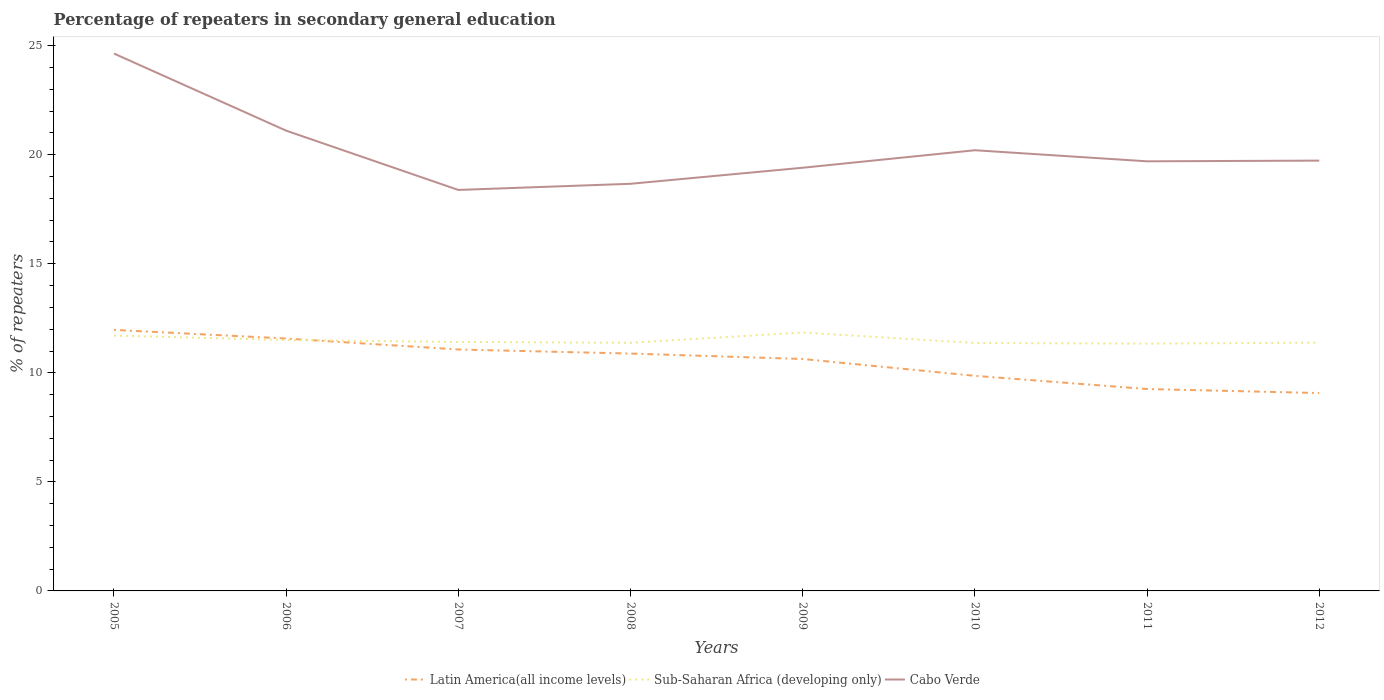Is the number of lines equal to the number of legend labels?
Make the answer very short. Yes. Across all years, what is the maximum percentage of repeaters in secondary general education in Cabo Verde?
Offer a terse response. 18.38. What is the total percentage of repeaters in secondary general education in Cabo Verde in the graph?
Offer a terse response. -0.29. What is the difference between the highest and the second highest percentage of repeaters in secondary general education in Cabo Verde?
Ensure brevity in your answer.  6.25. Is the percentage of repeaters in secondary general education in Cabo Verde strictly greater than the percentage of repeaters in secondary general education in Latin America(all income levels) over the years?
Give a very brief answer. No. How many years are there in the graph?
Ensure brevity in your answer.  8. Are the values on the major ticks of Y-axis written in scientific E-notation?
Make the answer very short. No. How many legend labels are there?
Ensure brevity in your answer.  3. What is the title of the graph?
Provide a short and direct response. Percentage of repeaters in secondary general education. Does "Poland" appear as one of the legend labels in the graph?
Your response must be concise. No. What is the label or title of the Y-axis?
Provide a succinct answer. % of repeaters. What is the % of repeaters of Latin America(all income levels) in 2005?
Your answer should be very brief. 11.97. What is the % of repeaters of Sub-Saharan Africa (developing only) in 2005?
Provide a short and direct response. 11.71. What is the % of repeaters of Cabo Verde in 2005?
Ensure brevity in your answer.  24.64. What is the % of repeaters of Latin America(all income levels) in 2006?
Ensure brevity in your answer.  11.57. What is the % of repeaters in Sub-Saharan Africa (developing only) in 2006?
Give a very brief answer. 11.5. What is the % of repeaters of Cabo Verde in 2006?
Offer a terse response. 21.1. What is the % of repeaters of Latin America(all income levels) in 2007?
Offer a very short reply. 11.07. What is the % of repeaters of Sub-Saharan Africa (developing only) in 2007?
Keep it short and to the point. 11.41. What is the % of repeaters in Cabo Verde in 2007?
Provide a succinct answer. 18.38. What is the % of repeaters of Latin America(all income levels) in 2008?
Provide a succinct answer. 10.88. What is the % of repeaters in Sub-Saharan Africa (developing only) in 2008?
Give a very brief answer. 11.38. What is the % of repeaters in Cabo Verde in 2008?
Offer a terse response. 18.67. What is the % of repeaters in Latin America(all income levels) in 2009?
Offer a terse response. 10.63. What is the % of repeaters of Sub-Saharan Africa (developing only) in 2009?
Provide a succinct answer. 11.85. What is the % of repeaters in Cabo Verde in 2009?
Keep it short and to the point. 19.4. What is the % of repeaters of Latin America(all income levels) in 2010?
Provide a succinct answer. 9.86. What is the % of repeaters in Sub-Saharan Africa (developing only) in 2010?
Provide a succinct answer. 11.37. What is the % of repeaters of Cabo Verde in 2010?
Make the answer very short. 20.2. What is the % of repeaters of Latin America(all income levels) in 2011?
Give a very brief answer. 9.26. What is the % of repeaters in Sub-Saharan Africa (developing only) in 2011?
Give a very brief answer. 11.34. What is the % of repeaters of Cabo Verde in 2011?
Ensure brevity in your answer.  19.7. What is the % of repeaters of Latin America(all income levels) in 2012?
Ensure brevity in your answer.  9.07. What is the % of repeaters in Sub-Saharan Africa (developing only) in 2012?
Provide a short and direct response. 11.38. What is the % of repeaters in Cabo Verde in 2012?
Make the answer very short. 19.73. Across all years, what is the maximum % of repeaters of Latin America(all income levels)?
Make the answer very short. 11.97. Across all years, what is the maximum % of repeaters in Sub-Saharan Africa (developing only)?
Provide a succinct answer. 11.85. Across all years, what is the maximum % of repeaters in Cabo Verde?
Your response must be concise. 24.64. Across all years, what is the minimum % of repeaters of Latin America(all income levels)?
Your answer should be very brief. 9.07. Across all years, what is the minimum % of repeaters of Sub-Saharan Africa (developing only)?
Keep it short and to the point. 11.34. Across all years, what is the minimum % of repeaters of Cabo Verde?
Your answer should be very brief. 18.38. What is the total % of repeaters in Latin America(all income levels) in the graph?
Make the answer very short. 84.32. What is the total % of repeaters of Sub-Saharan Africa (developing only) in the graph?
Offer a very short reply. 91.94. What is the total % of repeaters of Cabo Verde in the graph?
Your response must be concise. 161.82. What is the difference between the % of repeaters of Latin America(all income levels) in 2005 and that in 2006?
Keep it short and to the point. 0.4. What is the difference between the % of repeaters of Sub-Saharan Africa (developing only) in 2005 and that in 2006?
Your answer should be very brief. 0.2. What is the difference between the % of repeaters in Cabo Verde in 2005 and that in 2006?
Make the answer very short. 3.53. What is the difference between the % of repeaters of Latin America(all income levels) in 2005 and that in 2007?
Ensure brevity in your answer.  0.9. What is the difference between the % of repeaters of Sub-Saharan Africa (developing only) in 2005 and that in 2007?
Keep it short and to the point. 0.29. What is the difference between the % of repeaters in Cabo Verde in 2005 and that in 2007?
Provide a succinct answer. 6.25. What is the difference between the % of repeaters in Latin America(all income levels) in 2005 and that in 2008?
Your answer should be compact. 1.09. What is the difference between the % of repeaters in Sub-Saharan Africa (developing only) in 2005 and that in 2008?
Keep it short and to the point. 0.33. What is the difference between the % of repeaters of Cabo Verde in 2005 and that in 2008?
Keep it short and to the point. 5.97. What is the difference between the % of repeaters of Latin America(all income levels) in 2005 and that in 2009?
Your answer should be very brief. 1.33. What is the difference between the % of repeaters in Sub-Saharan Africa (developing only) in 2005 and that in 2009?
Offer a very short reply. -0.14. What is the difference between the % of repeaters of Cabo Verde in 2005 and that in 2009?
Ensure brevity in your answer.  5.24. What is the difference between the % of repeaters in Latin America(all income levels) in 2005 and that in 2010?
Make the answer very short. 2.11. What is the difference between the % of repeaters of Sub-Saharan Africa (developing only) in 2005 and that in 2010?
Provide a succinct answer. 0.34. What is the difference between the % of repeaters in Cabo Verde in 2005 and that in 2010?
Make the answer very short. 4.43. What is the difference between the % of repeaters in Latin America(all income levels) in 2005 and that in 2011?
Your response must be concise. 2.71. What is the difference between the % of repeaters in Sub-Saharan Africa (developing only) in 2005 and that in 2011?
Provide a succinct answer. 0.37. What is the difference between the % of repeaters in Cabo Verde in 2005 and that in 2011?
Offer a terse response. 4.94. What is the difference between the % of repeaters of Latin America(all income levels) in 2005 and that in 2012?
Give a very brief answer. 2.9. What is the difference between the % of repeaters in Sub-Saharan Africa (developing only) in 2005 and that in 2012?
Provide a short and direct response. 0.32. What is the difference between the % of repeaters in Cabo Verde in 2005 and that in 2012?
Your response must be concise. 4.91. What is the difference between the % of repeaters of Latin America(all income levels) in 2006 and that in 2007?
Your response must be concise. 0.5. What is the difference between the % of repeaters of Sub-Saharan Africa (developing only) in 2006 and that in 2007?
Ensure brevity in your answer.  0.09. What is the difference between the % of repeaters of Cabo Verde in 2006 and that in 2007?
Your answer should be compact. 2.72. What is the difference between the % of repeaters in Latin America(all income levels) in 2006 and that in 2008?
Keep it short and to the point. 0.69. What is the difference between the % of repeaters in Sub-Saharan Africa (developing only) in 2006 and that in 2008?
Your answer should be very brief. 0.12. What is the difference between the % of repeaters in Cabo Verde in 2006 and that in 2008?
Make the answer very short. 2.44. What is the difference between the % of repeaters of Latin America(all income levels) in 2006 and that in 2009?
Offer a terse response. 0.94. What is the difference between the % of repeaters of Sub-Saharan Africa (developing only) in 2006 and that in 2009?
Offer a terse response. -0.35. What is the difference between the % of repeaters of Cabo Verde in 2006 and that in 2009?
Offer a terse response. 1.7. What is the difference between the % of repeaters of Latin America(all income levels) in 2006 and that in 2010?
Ensure brevity in your answer.  1.71. What is the difference between the % of repeaters of Sub-Saharan Africa (developing only) in 2006 and that in 2010?
Your answer should be compact. 0.14. What is the difference between the % of repeaters of Cabo Verde in 2006 and that in 2010?
Your response must be concise. 0.9. What is the difference between the % of repeaters of Latin America(all income levels) in 2006 and that in 2011?
Your answer should be very brief. 2.31. What is the difference between the % of repeaters of Sub-Saharan Africa (developing only) in 2006 and that in 2011?
Your response must be concise. 0.16. What is the difference between the % of repeaters of Cabo Verde in 2006 and that in 2011?
Ensure brevity in your answer.  1.41. What is the difference between the % of repeaters of Latin America(all income levels) in 2006 and that in 2012?
Your answer should be very brief. 2.5. What is the difference between the % of repeaters in Sub-Saharan Africa (developing only) in 2006 and that in 2012?
Your answer should be very brief. 0.12. What is the difference between the % of repeaters of Cabo Verde in 2006 and that in 2012?
Offer a terse response. 1.37. What is the difference between the % of repeaters of Latin America(all income levels) in 2007 and that in 2008?
Your answer should be compact. 0.19. What is the difference between the % of repeaters in Sub-Saharan Africa (developing only) in 2007 and that in 2008?
Offer a terse response. 0.04. What is the difference between the % of repeaters of Cabo Verde in 2007 and that in 2008?
Provide a short and direct response. -0.28. What is the difference between the % of repeaters in Latin America(all income levels) in 2007 and that in 2009?
Provide a short and direct response. 0.44. What is the difference between the % of repeaters of Sub-Saharan Africa (developing only) in 2007 and that in 2009?
Provide a short and direct response. -0.43. What is the difference between the % of repeaters in Cabo Verde in 2007 and that in 2009?
Your response must be concise. -1.02. What is the difference between the % of repeaters of Latin America(all income levels) in 2007 and that in 2010?
Your response must be concise. 1.21. What is the difference between the % of repeaters in Sub-Saharan Africa (developing only) in 2007 and that in 2010?
Your answer should be very brief. 0.05. What is the difference between the % of repeaters in Cabo Verde in 2007 and that in 2010?
Your answer should be compact. -1.82. What is the difference between the % of repeaters in Latin America(all income levels) in 2007 and that in 2011?
Your answer should be compact. 1.81. What is the difference between the % of repeaters of Sub-Saharan Africa (developing only) in 2007 and that in 2011?
Keep it short and to the point. 0.08. What is the difference between the % of repeaters of Cabo Verde in 2007 and that in 2011?
Your answer should be very brief. -1.31. What is the difference between the % of repeaters of Latin America(all income levels) in 2007 and that in 2012?
Give a very brief answer. 2. What is the difference between the % of repeaters of Sub-Saharan Africa (developing only) in 2007 and that in 2012?
Ensure brevity in your answer.  0.03. What is the difference between the % of repeaters of Cabo Verde in 2007 and that in 2012?
Offer a terse response. -1.34. What is the difference between the % of repeaters in Latin America(all income levels) in 2008 and that in 2009?
Provide a short and direct response. 0.25. What is the difference between the % of repeaters in Sub-Saharan Africa (developing only) in 2008 and that in 2009?
Offer a terse response. -0.47. What is the difference between the % of repeaters of Cabo Verde in 2008 and that in 2009?
Provide a succinct answer. -0.74. What is the difference between the % of repeaters in Latin America(all income levels) in 2008 and that in 2010?
Your response must be concise. 1.02. What is the difference between the % of repeaters in Sub-Saharan Africa (developing only) in 2008 and that in 2010?
Ensure brevity in your answer.  0.01. What is the difference between the % of repeaters in Cabo Verde in 2008 and that in 2010?
Keep it short and to the point. -1.54. What is the difference between the % of repeaters of Latin America(all income levels) in 2008 and that in 2011?
Provide a succinct answer. 1.62. What is the difference between the % of repeaters of Sub-Saharan Africa (developing only) in 2008 and that in 2011?
Give a very brief answer. 0.04. What is the difference between the % of repeaters in Cabo Verde in 2008 and that in 2011?
Give a very brief answer. -1.03. What is the difference between the % of repeaters in Latin America(all income levels) in 2008 and that in 2012?
Provide a short and direct response. 1.81. What is the difference between the % of repeaters of Sub-Saharan Africa (developing only) in 2008 and that in 2012?
Your response must be concise. -0. What is the difference between the % of repeaters of Cabo Verde in 2008 and that in 2012?
Your answer should be very brief. -1.06. What is the difference between the % of repeaters in Latin America(all income levels) in 2009 and that in 2010?
Provide a succinct answer. 0.77. What is the difference between the % of repeaters in Sub-Saharan Africa (developing only) in 2009 and that in 2010?
Your answer should be very brief. 0.48. What is the difference between the % of repeaters of Cabo Verde in 2009 and that in 2010?
Your answer should be very brief. -0.8. What is the difference between the % of repeaters of Latin America(all income levels) in 2009 and that in 2011?
Provide a succinct answer. 1.38. What is the difference between the % of repeaters of Sub-Saharan Africa (developing only) in 2009 and that in 2011?
Your response must be concise. 0.51. What is the difference between the % of repeaters of Cabo Verde in 2009 and that in 2011?
Keep it short and to the point. -0.29. What is the difference between the % of repeaters in Latin America(all income levels) in 2009 and that in 2012?
Your answer should be compact. 1.56. What is the difference between the % of repeaters of Sub-Saharan Africa (developing only) in 2009 and that in 2012?
Make the answer very short. 0.47. What is the difference between the % of repeaters of Cabo Verde in 2009 and that in 2012?
Offer a very short reply. -0.33. What is the difference between the % of repeaters of Latin America(all income levels) in 2010 and that in 2011?
Your response must be concise. 0.6. What is the difference between the % of repeaters in Sub-Saharan Africa (developing only) in 2010 and that in 2011?
Make the answer very short. 0.03. What is the difference between the % of repeaters of Cabo Verde in 2010 and that in 2011?
Give a very brief answer. 0.51. What is the difference between the % of repeaters of Latin America(all income levels) in 2010 and that in 2012?
Make the answer very short. 0.79. What is the difference between the % of repeaters in Sub-Saharan Africa (developing only) in 2010 and that in 2012?
Your response must be concise. -0.01. What is the difference between the % of repeaters of Cabo Verde in 2010 and that in 2012?
Provide a short and direct response. 0.48. What is the difference between the % of repeaters of Latin America(all income levels) in 2011 and that in 2012?
Give a very brief answer. 0.18. What is the difference between the % of repeaters of Sub-Saharan Africa (developing only) in 2011 and that in 2012?
Your answer should be compact. -0.04. What is the difference between the % of repeaters in Cabo Verde in 2011 and that in 2012?
Your answer should be compact. -0.03. What is the difference between the % of repeaters in Latin America(all income levels) in 2005 and the % of repeaters in Sub-Saharan Africa (developing only) in 2006?
Give a very brief answer. 0.47. What is the difference between the % of repeaters of Latin America(all income levels) in 2005 and the % of repeaters of Cabo Verde in 2006?
Provide a short and direct response. -9.13. What is the difference between the % of repeaters in Sub-Saharan Africa (developing only) in 2005 and the % of repeaters in Cabo Verde in 2006?
Ensure brevity in your answer.  -9.4. What is the difference between the % of repeaters in Latin America(all income levels) in 2005 and the % of repeaters in Sub-Saharan Africa (developing only) in 2007?
Your response must be concise. 0.55. What is the difference between the % of repeaters in Latin America(all income levels) in 2005 and the % of repeaters in Cabo Verde in 2007?
Provide a succinct answer. -6.42. What is the difference between the % of repeaters in Sub-Saharan Africa (developing only) in 2005 and the % of repeaters in Cabo Verde in 2007?
Provide a succinct answer. -6.68. What is the difference between the % of repeaters of Latin America(all income levels) in 2005 and the % of repeaters of Sub-Saharan Africa (developing only) in 2008?
Offer a terse response. 0.59. What is the difference between the % of repeaters of Latin America(all income levels) in 2005 and the % of repeaters of Cabo Verde in 2008?
Your response must be concise. -6.7. What is the difference between the % of repeaters in Sub-Saharan Africa (developing only) in 2005 and the % of repeaters in Cabo Verde in 2008?
Keep it short and to the point. -6.96. What is the difference between the % of repeaters in Latin America(all income levels) in 2005 and the % of repeaters in Sub-Saharan Africa (developing only) in 2009?
Provide a succinct answer. 0.12. What is the difference between the % of repeaters in Latin America(all income levels) in 2005 and the % of repeaters in Cabo Verde in 2009?
Offer a very short reply. -7.43. What is the difference between the % of repeaters of Sub-Saharan Africa (developing only) in 2005 and the % of repeaters of Cabo Verde in 2009?
Give a very brief answer. -7.7. What is the difference between the % of repeaters in Latin America(all income levels) in 2005 and the % of repeaters in Sub-Saharan Africa (developing only) in 2010?
Offer a very short reply. 0.6. What is the difference between the % of repeaters of Latin America(all income levels) in 2005 and the % of repeaters of Cabo Verde in 2010?
Your answer should be compact. -8.24. What is the difference between the % of repeaters of Sub-Saharan Africa (developing only) in 2005 and the % of repeaters of Cabo Verde in 2010?
Provide a short and direct response. -8.5. What is the difference between the % of repeaters of Latin America(all income levels) in 2005 and the % of repeaters of Sub-Saharan Africa (developing only) in 2011?
Keep it short and to the point. 0.63. What is the difference between the % of repeaters in Latin America(all income levels) in 2005 and the % of repeaters in Cabo Verde in 2011?
Ensure brevity in your answer.  -7.73. What is the difference between the % of repeaters in Sub-Saharan Africa (developing only) in 2005 and the % of repeaters in Cabo Verde in 2011?
Ensure brevity in your answer.  -7.99. What is the difference between the % of repeaters of Latin America(all income levels) in 2005 and the % of repeaters of Sub-Saharan Africa (developing only) in 2012?
Your answer should be very brief. 0.59. What is the difference between the % of repeaters in Latin America(all income levels) in 2005 and the % of repeaters in Cabo Verde in 2012?
Provide a short and direct response. -7.76. What is the difference between the % of repeaters of Sub-Saharan Africa (developing only) in 2005 and the % of repeaters of Cabo Verde in 2012?
Provide a succinct answer. -8.02. What is the difference between the % of repeaters in Latin America(all income levels) in 2006 and the % of repeaters in Sub-Saharan Africa (developing only) in 2007?
Ensure brevity in your answer.  0.16. What is the difference between the % of repeaters in Latin America(all income levels) in 2006 and the % of repeaters in Cabo Verde in 2007?
Your answer should be very brief. -6.81. What is the difference between the % of repeaters of Sub-Saharan Africa (developing only) in 2006 and the % of repeaters of Cabo Verde in 2007?
Your answer should be compact. -6.88. What is the difference between the % of repeaters in Latin America(all income levels) in 2006 and the % of repeaters in Sub-Saharan Africa (developing only) in 2008?
Ensure brevity in your answer.  0.19. What is the difference between the % of repeaters in Latin America(all income levels) in 2006 and the % of repeaters in Cabo Verde in 2008?
Provide a short and direct response. -7.1. What is the difference between the % of repeaters of Sub-Saharan Africa (developing only) in 2006 and the % of repeaters of Cabo Verde in 2008?
Offer a very short reply. -7.16. What is the difference between the % of repeaters of Latin America(all income levels) in 2006 and the % of repeaters of Sub-Saharan Africa (developing only) in 2009?
Keep it short and to the point. -0.28. What is the difference between the % of repeaters of Latin America(all income levels) in 2006 and the % of repeaters of Cabo Verde in 2009?
Ensure brevity in your answer.  -7.83. What is the difference between the % of repeaters in Sub-Saharan Africa (developing only) in 2006 and the % of repeaters in Cabo Verde in 2009?
Your response must be concise. -7.9. What is the difference between the % of repeaters in Latin America(all income levels) in 2006 and the % of repeaters in Sub-Saharan Africa (developing only) in 2010?
Provide a short and direct response. 0.2. What is the difference between the % of repeaters in Latin America(all income levels) in 2006 and the % of repeaters in Cabo Verde in 2010?
Ensure brevity in your answer.  -8.63. What is the difference between the % of repeaters of Sub-Saharan Africa (developing only) in 2006 and the % of repeaters of Cabo Verde in 2010?
Offer a very short reply. -8.7. What is the difference between the % of repeaters in Latin America(all income levels) in 2006 and the % of repeaters in Sub-Saharan Africa (developing only) in 2011?
Ensure brevity in your answer.  0.23. What is the difference between the % of repeaters of Latin America(all income levels) in 2006 and the % of repeaters of Cabo Verde in 2011?
Make the answer very short. -8.13. What is the difference between the % of repeaters of Sub-Saharan Africa (developing only) in 2006 and the % of repeaters of Cabo Verde in 2011?
Your answer should be compact. -8.19. What is the difference between the % of repeaters in Latin America(all income levels) in 2006 and the % of repeaters in Sub-Saharan Africa (developing only) in 2012?
Keep it short and to the point. 0.19. What is the difference between the % of repeaters in Latin America(all income levels) in 2006 and the % of repeaters in Cabo Verde in 2012?
Offer a terse response. -8.16. What is the difference between the % of repeaters in Sub-Saharan Africa (developing only) in 2006 and the % of repeaters in Cabo Verde in 2012?
Make the answer very short. -8.23. What is the difference between the % of repeaters of Latin America(all income levels) in 2007 and the % of repeaters of Sub-Saharan Africa (developing only) in 2008?
Ensure brevity in your answer.  -0.31. What is the difference between the % of repeaters of Latin America(all income levels) in 2007 and the % of repeaters of Cabo Verde in 2008?
Provide a succinct answer. -7.6. What is the difference between the % of repeaters in Sub-Saharan Africa (developing only) in 2007 and the % of repeaters in Cabo Verde in 2008?
Offer a terse response. -7.25. What is the difference between the % of repeaters in Latin America(all income levels) in 2007 and the % of repeaters in Sub-Saharan Africa (developing only) in 2009?
Provide a short and direct response. -0.78. What is the difference between the % of repeaters in Latin America(all income levels) in 2007 and the % of repeaters in Cabo Verde in 2009?
Your response must be concise. -8.33. What is the difference between the % of repeaters of Sub-Saharan Africa (developing only) in 2007 and the % of repeaters of Cabo Verde in 2009?
Make the answer very short. -7.99. What is the difference between the % of repeaters of Latin America(all income levels) in 2007 and the % of repeaters of Sub-Saharan Africa (developing only) in 2010?
Make the answer very short. -0.3. What is the difference between the % of repeaters of Latin America(all income levels) in 2007 and the % of repeaters of Cabo Verde in 2010?
Provide a short and direct response. -9.14. What is the difference between the % of repeaters of Sub-Saharan Africa (developing only) in 2007 and the % of repeaters of Cabo Verde in 2010?
Keep it short and to the point. -8.79. What is the difference between the % of repeaters of Latin America(all income levels) in 2007 and the % of repeaters of Sub-Saharan Africa (developing only) in 2011?
Your answer should be compact. -0.27. What is the difference between the % of repeaters in Latin America(all income levels) in 2007 and the % of repeaters in Cabo Verde in 2011?
Provide a short and direct response. -8.63. What is the difference between the % of repeaters in Sub-Saharan Africa (developing only) in 2007 and the % of repeaters in Cabo Verde in 2011?
Offer a very short reply. -8.28. What is the difference between the % of repeaters of Latin America(all income levels) in 2007 and the % of repeaters of Sub-Saharan Africa (developing only) in 2012?
Ensure brevity in your answer.  -0.31. What is the difference between the % of repeaters in Latin America(all income levels) in 2007 and the % of repeaters in Cabo Verde in 2012?
Provide a succinct answer. -8.66. What is the difference between the % of repeaters in Sub-Saharan Africa (developing only) in 2007 and the % of repeaters in Cabo Verde in 2012?
Offer a very short reply. -8.31. What is the difference between the % of repeaters in Latin America(all income levels) in 2008 and the % of repeaters in Sub-Saharan Africa (developing only) in 2009?
Your response must be concise. -0.97. What is the difference between the % of repeaters of Latin America(all income levels) in 2008 and the % of repeaters of Cabo Verde in 2009?
Provide a short and direct response. -8.52. What is the difference between the % of repeaters of Sub-Saharan Africa (developing only) in 2008 and the % of repeaters of Cabo Verde in 2009?
Make the answer very short. -8.02. What is the difference between the % of repeaters of Latin America(all income levels) in 2008 and the % of repeaters of Sub-Saharan Africa (developing only) in 2010?
Keep it short and to the point. -0.49. What is the difference between the % of repeaters in Latin America(all income levels) in 2008 and the % of repeaters in Cabo Verde in 2010?
Offer a terse response. -9.32. What is the difference between the % of repeaters in Sub-Saharan Africa (developing only) in 2008 and the % of repeaters in Cabo Verde in 2010?
Provide a short and direct response. -8.83. What is the difference between the % of repeaters of Latin America(all income levels) in 2008 and the % of repeaters of Sub-Saharan Africa (developing only) in 2011?
Give a very brief answer. -0.46. What is the difference between the % of repeaters in Latin America(all income levels) in 2008 and the % of repeaters in Cabo Verde in 2011?
Make the answer very short. -8.81. What is the difference between the % of repeaters in Sub-Saharan Africa (developing only) in 2008 and the % of repeaters in Cabo Verde in 2011?
Give a very brief answer. -8.32. What is the difference between the % of repeaters in Latin America(all income levels) in 2008 and the % of repeaters in Sub-Saharan Africa (developing only) in 2012?
Your response must be concise. -0.5. What is the difference between the % of repeaters in Latin America(all income levels) in 2008 and the % of repeaters in Cabo Verde in 2012?
Give a very brief answer. -8.85. What is the difference between the % of repeaters of Sub-Saharan Africa (developing only) in 2008 and the % of repeaters of Cabo Verde in 2012?
Provide a short and direct response. -8.35. What is the difference between the % of repeaters of Latin America(all income levels) in 2009 and the % of repeaters of Sub-Saharan Africa (developing only) in 2010?
Make the answer very short. -0.73. What is the difference between the % of repeaters in Latin America(all income levels) in 2009 and the % of repeaters in Cabo Verde in 2010?
Provide a short and direct response. -9.57. What is the difference between the % of repeaters of Sub-Saharan Africa (developing only) in 2009 and the % of repeaters of Cabo Verde in 2010?
Keep it short and to the point. -8.36. What is the difference between the % of repeaters of Latin America(all income levels) in 2009 and the % of repeaters of Sub-Saharan Africa (developing only) in 2011?
Offer a terse response. -0.7. What is the difference between the % of repeaters in Latin America(all income levels) in 2009 and the % of repeaters in Cabo Verde in 2011?
Offer a very short reply. -9.06. What is the difference between the % of repeaters in Sub-Saharan Africa (developing only) in 2009 and the % of repeaters in Cabo Verde in 2011?
Give a very brief answer. -7.85. What is the difference between the % of repeaters of Latin America(all income levels) in 2009 and the % of repeaters of Sub-Saharan Africa (developing only) in 2012?
Give a very brief answer. -0.75. What is the difference between the % of repeaters in Latin America(all income levels) in 2009 and the % of repeaters in Cabo Verde in 2012?
Keep it short and to the point. -9.1. What is the difference between the % of repeaters in Sub-Saharan Africa (developing only) in 2009 and the % of repeaters in Cabo Verde in 2012?
Offer a terse response. -7.88. What is the difference between the % of repeaters of Latin America(all income levels) in 2010 and the % of repeaters of Sub-Saharan Africa (developing only) in 2011?
Offer a very short reply. -1.48. What is the difference between the % of repeaters in Latin America(all income levels) in 2010 and the % of repeaters in Cabo Verde in 2011?
Your answer should be very brief. -9.84. What is the difference between the % of repeaters in Sub-Saharan Africa (developing only) in 2010 and the % of repeaters in Cabo Verde in 2011?
Provide a short and direct response. -8.33. What is the difference between the % of repeaters in Latin America(all income levels) in 2010 and the % of repeaters in Sub-Saharan Africa (developing only) in 2012?
Ensure brevity in your answer.  -1.52. What is the difference between the % of repeaters in Latin America(all income levels) in 2010 and the % of repeaters in Cabo Verde in 2012?
Your answer should be very brief. -9.87. What is the difference between the % of repeaters in Sub-Saharan Africa (developing only) in 2010 and the % of repeaters in Cabo Verde in 2012?
Your response must be concise. -8.36. What is the difference between the % of repeaters of Latin America(all income levels) in 2011 and the % of repeaters of Sub-Saharan Africa (developing only) in 2012?
Make the answer very short. -2.13. What is the difference between the % of repeaters of Latin America(all income levels) in 2011 and the % of repeaters of Cabo Verde in 2012?
Your response must be concise. -10.47. What is the difference between the % of repeaters in Sub-Saharan Africa (developing only) in 2011 and the % of repeaters in Cabo Verde in 2012?
Give a very brief answer. -8.39. What is the average % of repeaters in Latin America(all income levels) per year?
Provide a short and direct response. 10.54. What is the average % of repeaters of Sub-Saharan Africa (developing only) per year?
Your answer should be very brief. 11.49. What is the average % of repeaters in Cabo Verde per year?
Offer a very short reply. 20.23. In the year 2005, what is the difference between the % of repeaters in Latin America(all income levels) and % of repeaters in Sub-Saharan Africa (developing only)?
Provide a short and direct response. 0.26. In the year 2005, what is the difference between the % of repeaters in Latin America(all income levels) and % of repeaters in Cabo Verde?
Provide a short and direct response. -12.67. In the year 2005, what is the difference between the % of repeaters in Sub-Saharan Africa (developing only) and % of repeaters in Cabo Verde?
Ensure brevity in your answer.  -12.93. In the year 2006, what is the difference between the % of repeaters of Latin America(all income levels) and % of repeaters of Sub-Saharan Africa (developing only)?
Make the answer very short. 0.07. In the year 2006, what is the difference between the % of repeaters in Latin America(all income levels) and % of repeaters in Cabo Verde?
Your answer should be very brief. -9.53. In the year 2006, what is the difference between the % of repeaters in Sub-Saharan Africa (developing only) and % of repeaters in Cabo Verde?
Your response must be concise. -9.6. In the year 2007, what is the difference between the % of repeaters in Latin America(all income levels) and % of repeaters in Sub-Saharan Africa (developing only)?
Provide a succinct answer. -0.35. In the year 2007, what is the difference between the % of repeaters of Latin America(all income levels) and % of repeaters of Cabo Verde?
Your answer should be compact. -7.32. In the year 2007, what is the difference between the % of repeaters in Sub-Saharan Africa (developing only) and % of repeaters in Cabo Verde?
Your response must be concise. -6.97. In the year 2008, what is the difference between the % of repeaters of Latin America(all income levels) and % of repeaters of Sub-Saharan Africa (developing only)?
Offer a terse response. -0.5. In the year 2008, what is the difference between the % of repeaters of Latin America(all income levels) and % of repeaters of Cabo Verde?
Offer a terse response. -7.78. In the year 2008, what is the difference between the % of repeaters in Sub-Saharan Africa (developing only) and % of repeaters in Cabo Verde?
Ensure brevity in your answer.  -7.29. In the year 2009, what is the difference between the % of repeaters of Latin America(all income levels) and % of repeaters of Sub-Saharan Africa (developing only)?
Give a very brief answer. -1.21. In the year 2009, what is the difference between the % of repeaters of Latin America(all income levels) and % of repeaters of Cabo Verde?
Offer a terse response. -8.77. In the year 2009, what is the difference between the % of repeaters in Sub-Saharan Africa (developing only) and % of repeaters in Cabo Verde?
Your response must be concise. -7.55. In the year 2010, what is the difference between the % of repeaters in Latin America(all income levels) and % of repeaters in Sub-Saharan Africa (developing only)?
Your response must be concise. -1.51. In the year 2010, what is the difference between the % of repeaters in Latin America(all income levels) and % of repeaters in Cabo Verde?
Provide a short and direct response. -10.34. In the year 2010, what is the difference between the % of repeaters of Sub-Saharan Africa (developing only) and % of repeaters of Cabo Verde?
Your response must be concise. -8.84. In the year 2011, what is the difference between the % of repeaters in Latin America(all income levels) and % of repeaters in Sub-Saharan Africa (developing only)?
Give a very brief answer. -2.08. In the year 2011, what is the difference between the % of repeaters of Latin America(all income levels) and % of repeaters of Cabo Verde?
Offer a very short reply. -10.44. In the year 2011, what is the difference between the % of repeaters in Sub-Saharan Africa (developing only) and % of repeaters in Cabo Verde?
Keep it short and to the point. -8.36. In the year 2012, what is the difference between the % of repeaters of Latin America(all income levels) and % of repeaters of Sub-Saharan Africa (developing only)?
Make the answer very short. -2.31. In the year 2012, what is the difference between the % of repeaters of Latin America(all income levels) and % of repeaters of Cabo Verde?
Ensure brevity in your answer.  -10.66. In the year 2012, what is the difference between the % of repeaters of Sub-Saharan Africa (developing only) and % of repeaters of Cabo Verde?
Provide a succinct answer. -8.35. What is the ratio of the % of repeaters of Latin America(all income levels) in 2005 to that in 2006?
Your response must be concise. 1.03. What is the ratio of the % of repeaters in Sub-Saharan Africa (developing only) in 2005 to that in 2006?
Your answer should be very brief. 1.02. What is the ratio of the % of repeaters in Cabo Verde in 2005 to that in 2006?
Ensure brevity in your answer.  1.17. What is the ratio of the % of repeaters in Latin America(all income levels) in 2005 to that in 2007?
Make the answer very short. 1.08. What is the ratio of the % of repeaters of Sub-Saharan Africa (developing only) in 2005 to that in 2007?
Provide a succinct answer. 1.03. What is the ratio of the % of repeaters in Cabo Verde in 2005 to that in 2007?
Offer a terse response. 1.34. What is the ratio of the % of repeaters in Latin America(all income levels) in 2005 to that in 2008?
Provide a succinct answer. 1.1. What is the ratio of the % of repeaters of Sub-Saharan Africa (developing only) in 2005 to that in 2008?
Offer a very short reply. 1.03. What is the ratio of the % of repeaters in Cabo Verde in 2005 to that in 2008?
Your response must be concise. 1.32. What is the ratio of the % of repeaters of Latin America(all income levels) in 2005 to that in 2009?
Make the answer very short. 1.13. What is the ratio of the % of repeaters of Sub-Saharan Africa (developing only) in 2005 to that in 2009?
Keep it short and to the point. 0.99. What is the ratio of the % of repeaters of Cabo Verde in 2005 to that in 2009?
Keep it short and to the point. 1.27. What is the ratio of the % of repeaters in Latin America(all income levels) in 2005 to that in 2010?
Give a very brief answer. 1.21. What is the ratio of the % of repeaters of Sub-Saharan Africa (developing only) in 2005 to that in 2010?
Offer a terse response. 1.03. What is the ratio of the % of repeaters of Cabo Verde in 2005 to that in 2010?
Your answer should be very brief. 1.22. What is the ratio of the % of repeaters of Latin America(all income levels) in 2005 to that in 2011?
Ensure brevity in your answer.  1.29. What is the ratio of the % of repeaters of Sub-Saharan Africa (developing only) in 2005 to that in 2011?
Keep it short and to the point. 1.03. What is the ratio of the % of repeaters of Cabo Verde in 2005 to that in 2011?
Provide a succinct answer. 1.25. What is the ratio of the % of repeaters in Latin America(all income levels) in 2005 to that in 2012?
Provide a succinct answer. 1.32. What is the ratio of the % of repeaters in Sub-Saharan Africa (developing only) in 2005 to that in 2012?
Offer a terse response. 1.03. What is the ratio of the % of repeaters in Cabo Verde in 2005 to that in 2012?
Your answer should be very brief. 1.25. What is the ratio of the % of repeaters of Latin America(all income levels) in 2006 to that in 2007?
Ensure brevity in your answer.  1.05. What is the ratio of the % of repeaters of Sub-Saharan Africa (developing only) in 2006 to that in 2007?
Make the answer very short. 1.01. What is the ratio of the % of repeaters in Cabo Verde in 2006 to that in 2007?
Your answer should be compact. 1.15. What is the ratio of the % of repeaters in Latin America(all income levels) in 2006 to that in 2008?
Offer a terse response. 1.06. What is the ratio of the % of repeaters in Sub-Saharan Africa (developing only) in 2006 to that in 2008?
Your answer should be compact. 1.01. What is the ratio of the % of repeaters of Cabo Verde in 2006 to that in 2008?
Your answer should be compact. 1.13. What is the ratio of the % of repeaters in Latin America(all income levels) in 2006 to that in 2009?
Provide a short and direct response. 1.09. What is the ratio of the % of repeaters in Sub-Saharan Africa (developing only) in 2006 to that in 2009?
Offer a very short reply. 0.97. What is the ratio of the % of repeaters of Cabo Verde in 2006 to that in 2009?
Your response must be concise. 1.09. What is the ratio of the % of repeaters of Latin America(all income levels) in 2006 to that in 2010?
Your answer should be very brief. 1.17. What is the ratio of the % of repeaters in Sub-Saharan Africa (developing only) in 2006 to that in 2010?
Offer a very short reply. 1.01. What is the ratio of the % of repeaters in Cabo Verde in 2006 to that in 2010?
Offer a terse response. 1.04. What is the ratio of the % of repeaters of Sub-Saharan Africa (developing only) in 2006 to that in 2011?
Offer a terse response. 1.01. What is the ratio of the % of repeaters of Cabo Verde in 2006 to that in 2011?
Offer a very short reply. 1.07. What is the ratio of the % of repeaters in Latin America(all income levels) in 2006 to that in 2012?
Offer a very short reply. 1.28. What is the ratio of the % of repeaters in Sub-Saharan Africa (developing only) in 2006 to that in 2012?
Your answer should be very brief. 1.01. What is the ratio of the % of repeaters of Cabo Verde in 2006 to that in 2012?
Make the answer very short. 1.07. What is the ratio of the % of repeaters in Latin America(all income levels) in 2007 to that in 2008?
Offer a terse response. 1.02. What is the ratio of the % of repeaters of Cabo Verde in 2007 to that in 2008?
Keep it short and to the point. 0.98. What is the ratio of the % of repeaters in Latin America(all income levels) in 2007 to that in 2009?
Ensure brevity in your answer.  1.04. What is the ratio of the % of repeaters of Sub-Saharan Africa (developing only) in 2007 to that in 2009?
Make the answer very short. 0.96. What is the ratio of the % of repeaters in Cabo Verde in 2007 to that in 2009?
Give a very brief answer. 0.95. What is the ratio of the % of repeaters in Latin America(all income levels) in 2007 to that in 2010?
Ensure brevity in your answer.  1.12. What is the ratio of the % of repeaters of Cabo Verde in 2007 to that in 2010?
Your answer should be compact. 0.91. What is the ratio of the % of repeaters of Latin America(all income levels) in 2007 to that in 2011?
Offer a terse response. 1.2. What is the ratio of the % of repeaters of Cabo Verde in 2007 to that in 2011?
Provide a short and direct response. 0.93. What is the ratio of the % of repeaters of Latin America(all income levels) in 2007 to that in 2012?
Give a very brief answer. 1.22. What is the ratio of the % of repeaters of Sub-Saharan Africa (developing only) in 2007 to that in 2012?
Offer a terse response. 1. What is the ratio of the % of repeaters of Cabo Verde in 2007 to that in 2012?
Your answer should be very brief. 0.93. What is the ratio of the % of repeaters in Latin America(all income levels) in 2008 to that in 2009?
Your response must be concise. 1.02. What is the ratio of the % of repeaters in Sub-Saharan Africa (developing only) in 2008 to that in 2009?
Your answer should be very brief. 0.96. What is the ratio of the % of repeaters of Cabo Verde in 2008 to that in 2009?
Offer a very short reply. 0.96. What is the ratio of the % of repeaters of Latin America(all income levels) in 2008 to that in 2010?
Provide a succinct answer. 1.1. What is the ratio of the % of repeaters in Cabo Verde in 2008 to that in 2010?
Provide a short and direct response. 0.92. What is the ratio of the % of repeaters in Latin America(all income levels) in 2008 to that in 2011?
Your answer should be compact. 1.18. What is the ratio of the % of repeaters of Sub-Saharan Africa (developing only) in 2008 to that in 2011?
Provide a short and direct response. 1. What is the ratio of the % of repeaters of Cabo Verde in 2008 to that in 2011?
Offer a very short reply. 0.95. What is the ratio of the % of repeaters in Latin America(all income levels) in 2008 to that in 2012?
Your answer should be compact. 1.2. What is the ratio of the % of repeaters of Cabo Verde in 2008 to that in 2012?
Offer a terse response. 0.95. What is the ratio of the % of repeaters of Latin America(all income levels) in 2009 to that in 2010?
Give a very brief answer. 1.08. What is the ratio of the % of repeaters of Sub-Saharan Africa (developing only) in 2009 to that in 2010?
Offer a terse response. 1.04. What is the ratio of the % of repeaters of Cabo Verde in 2009 to that in 2010?
Your answer should be very brief. 0.96. What is the ratio of the % of repeaters of Latin America(all income levels) in 2009 to that in 2011?
Offer a terse response. 1.15. What is the ratio of the % of repeaters of Sub-Saharan Africa (developing only) in 2009 to that in 2011?
Your answer should be compact. 1.04. What is the ratio of the % of repeaters in Cabo Verde in 2009 to that in 2011?
Provide a succinct answer. 0.98. What is the ratio of the % of repeaters in Latin America(all income levels) in 2009 to that in 2012?
Make the answer very short. 1.17. What is the ratio of the % of repeaters in Sub-Saharan Africa (developing only) in 2009 to that in 2012?
Provide a short and direct response. 1.04. What is the ratio of the % of repeaters in Cabo Verde in 2009 to that in 2012?
Your answer should be very brief. 0.98. What is the ratio of the % of repeaters of Latin America(all income levels) in 2010 to that in 2011?
Your answer should be compact. 1.07. What is the ratio of the % of repeaters in Cabo Verde in 2010 to that in 2011?
Keep it short and to the point. 1.03. What is the ratio of the % of repeaters in Latin America(all income levels) in 2010 to that in 2012?
Offer a very short reply. 1.09. What is the ratio of the % of repeaters of Cabo Verde in 2010 to that in 2012?
Keep it short and to the point. 1.02. What is the ratio of the % of repeaters in Latin America(all income levels) in 2011 to that in 2012?
Your answer should be very brief. 1.02. What is the ratio of the % of repeaters of Sub-Saharan Africa (developing only) in 2011 to that in 2012?
Offer a very short reply. 1. What is the difference between the highest and the second highest % of repeaters in Latin America(all income levels)?
Your answer should be compact. 0.4. What is the difference between the highest and the second highest % of repeaters of Sub-Saharan Africa (developing only)?
Provide a short and direct response. 0.14. What is the difference between the highest and the second highest % of repeaters in Cabo Verde?
Provide a short and direct response. 3.53. What is the difference between the highest and the lowest % of repeaters of Latin America(all income levels)?
Offer a very short reply. 2.9. What is the difference between the highest and the lowest % of repeaters of Sub-Saharan Africa (developing only)?
Your answer should be very brief. 0.51. What is the difference between the highest and the lowest % of repeaters in Cabo Verde?
Keep it short and to the point. 6.25. 